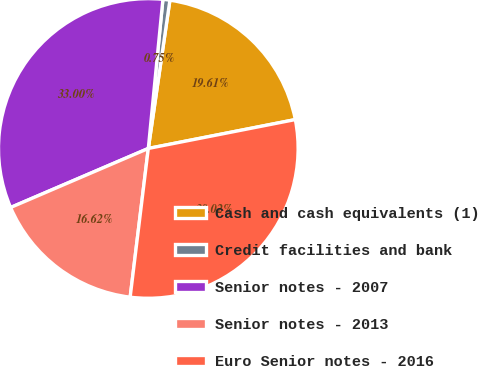Convert chart to OTSL. <chart><loc_0><loc_0><loc_500><loc_500><pie_chart><fcel>Cash and cash equivalents (1)<fcel>Credit facilities and bank<fcel>Senior notes - 2007<fcel>Senior notes - 2013<fcel>Euro Senior notes - 2016<nl><fcel>19.61%<fcel>0.75%<fcel>33.0%<fcel>16.62%<fcel>30.02%<nl></chart> 